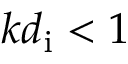<formula> <loc_0><loc_0><loc_500><loc_500>k d _ { i } < 1</formula> 